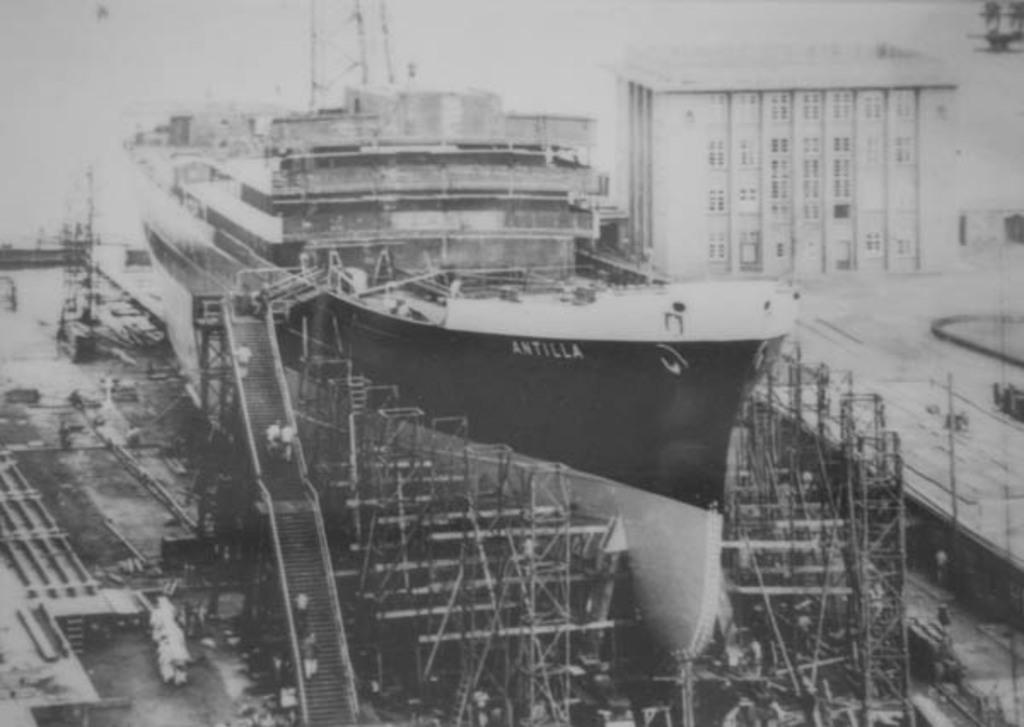<image>
Give a short and clear explanation of the subsequent image. A black and white photograph of the ship Antilla 